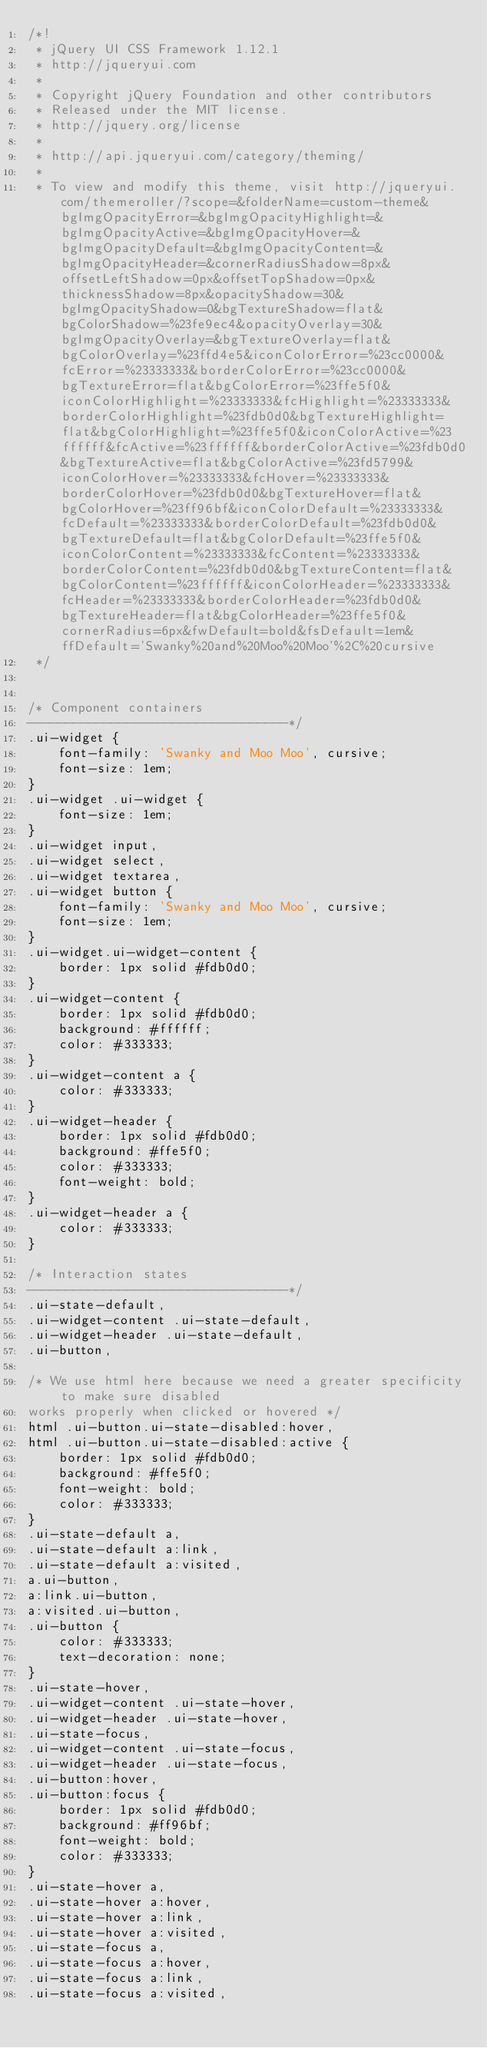Convert code to text. <code><loc_0><loc_0><loc_500><loc_500><_CSS_>/*!
 * jQuery UI CSS Framework 1.12.1
 * http://jqueryui.com
 *
 * Copyright jQuery Foundation and other contributors
 * Released under the MIT license.
 * http://jquery.org/license
 *
 * http://api.jqueryui.com/category/theming/
 *
 * To view and modify this theme, visit http://jqueryui.com/themeroller/?scope=&folderName=custom-theme&bgImgOpacityError=&bgImgOpacityHighlight=&bgImgOpacityActive=&bgImgOpacityHover=&bgImgOpacityDefault=&bgImgOpacityContent=&bgImgOpacityHeader=&cornerRadiusShadow=8px&offsetLeftShadow=0px&offsetTopShadow=0px&thicknessShadow=8px&opacityShadow=30&bgImgOpacityShadow=0&bgTextureShadow=flat&bgColorShadow=%23fe9ec4&opacityOverlay=30&bgImgOpacityOverlay=&bgTextureOverlay=flat&bgColorOverlay=%23ffd4e5&iconColorError=%23cc0000&fcError=%23333333&borderColorError=%23cc0000&bgTextureError=flat&bgColorError=%23ffe5f0&iconColorHighlight=%23333333&fcHighlight=%23333333&borderColorHighlight=%23fdb0d0&bgTextureHighlight=flat&bgColorHighlight=%23ffe5f0&iconColorActive=%23ffffff&fcActive=%23ffffff&borderColorActive=%23fdb0d0&bgTextureActive=flat&bgColorActive=%23fd5799&iconColorHover=%23333333&fcHover=%23333333&borderColorHover=%23fdb0d0&bgTextureHover=flat&bgColorHover=%23ff96bf&iconColorDefault=%23333333&fcDefault=%23333333&borderColorDefault=%23fdb0d0&bgTextureDefault=flat&bgColorDefault=%23ffe5f0&iconColorContent=%23333333&fcContent=%23333333&borderColorContent=%23fdb0d0&bgTextureContent=flat&bgColorContent=%23ffffff&iconColorHeader=%23333333&fcHeader=%23333333&borderColorHeader=%23fdb0d0&bgTextureHeader=flat&bgColorHeader=%23ffe5f0&cornerRadius=6px&fwDefault=bold&fsDefault=1em&ffDefault='Swanky%20and%20Moo%20Moo'%2C%20cursive
 */


/* Component containers
----------------------------------*/
.ui-widget {
	font-family: 'Swanky and Moo Moo', cursive;
	font-size: 1em;
}
.ui-widget .ui-widget {
	font-size: 1em;
}
.ui-widget input,
.ui-widget select,
.ui-widget textarea,
.ui-widget button {
	font-family: 'Swanky and Moo Moo', cursive;
	font-size: 1em;
}
.ui-widget.ui-widget-content {
	border: 1px solid #fdb0d0;
}
.ui-widget-content {
	border: 1px solid #fdb0d0;
	background: #ffffff;
	color: #333333;
}
.ui-widget-content a {
	color: #333333;
}
.ui-widget-header {
	border: 1px solid #fdb0d0;
	background: #ffe5f0;
	color: #333333;
	font-weight: bold;
}
.ui-widget-header a {
	color: #333333;
}

/* Interaction states
----------------------------------*/
.ui-state-default,
.ui-widget-content .ui-state-default,
.ui-widget-header .ui-state-default,
.ui-button,

/* We use html here because we need a greater specificity to make sure disabled
works properly when clicked or hovered */
html .ui-button.ui-state-disabled:hover,
html .ui-button.ui-state-disabled:active {
	border: 1px solid #fdb0d0;
	background: #ffe5f0;
	font-weight: bold;
	color: #333333;
}
.ui-state-default a,
.ui-state-default a:link,
.ui-state-default a:visited,
a.ui-button,
a:link.ui-button,
a:visited.ui-button,
.ui-button {
	color: #333333;
	text-decoration: none;
}
.ui-state-hover,
.ui-widget-content .ui-state-hover,
.ui-widget-header .ui-state-hover,
.ui-state-focus,
.ui-widget-content .ui-state-focus,
.ui-widget-header .ui-state-focus,
.ui-button:hover,
.ui-button:focus {
	border: 1px solid #fdb0d0;
	background: #ff96bf;
	font-weight: bold;
	color: #333333;
}
.ui-state-hover a,
.ui-state-hover a:hover,
.ui-state-hover a:link,
.ui-state-hover a:visited,
.ui-state-focus a,
.ui-state-focus a:hover,
.ui-state-focus a:link,
.ui-state-focus a:visited,</code> 